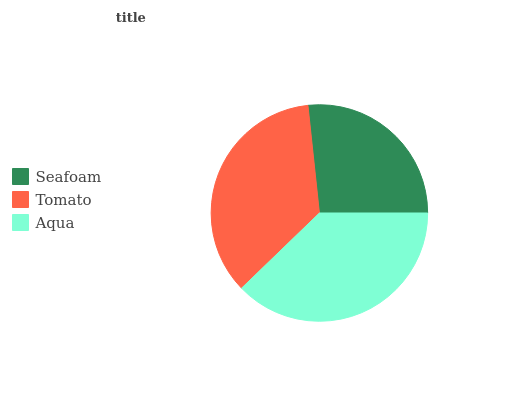Is Seafoam the minimum?
Answer yes or no. Yes. Is Aqua the maximum?
Answer yes or no. Yes. Is Tomato the minimum?
Answer yes or no. No. Is Tomato the maximum?
Answer yes or no. No. Is Tomato greater than Seafoam?
Answer yes or no. Yes. Is Seafoam less than Tomato?
Answer yes or no. Yes. Is Seafoam greater than Tomato?
Answer yes or no. No. Is Tomato less than Seafoam?
Answer yes or no. No. Is Tomato the high median?
Answer yes or no. Yes. Is Tomato the low median?
Answer yes or no. Yes. Is Aqua the high median?
Answer yes or no. No. Is Aqua the low median?
Answer yes or no. No. 